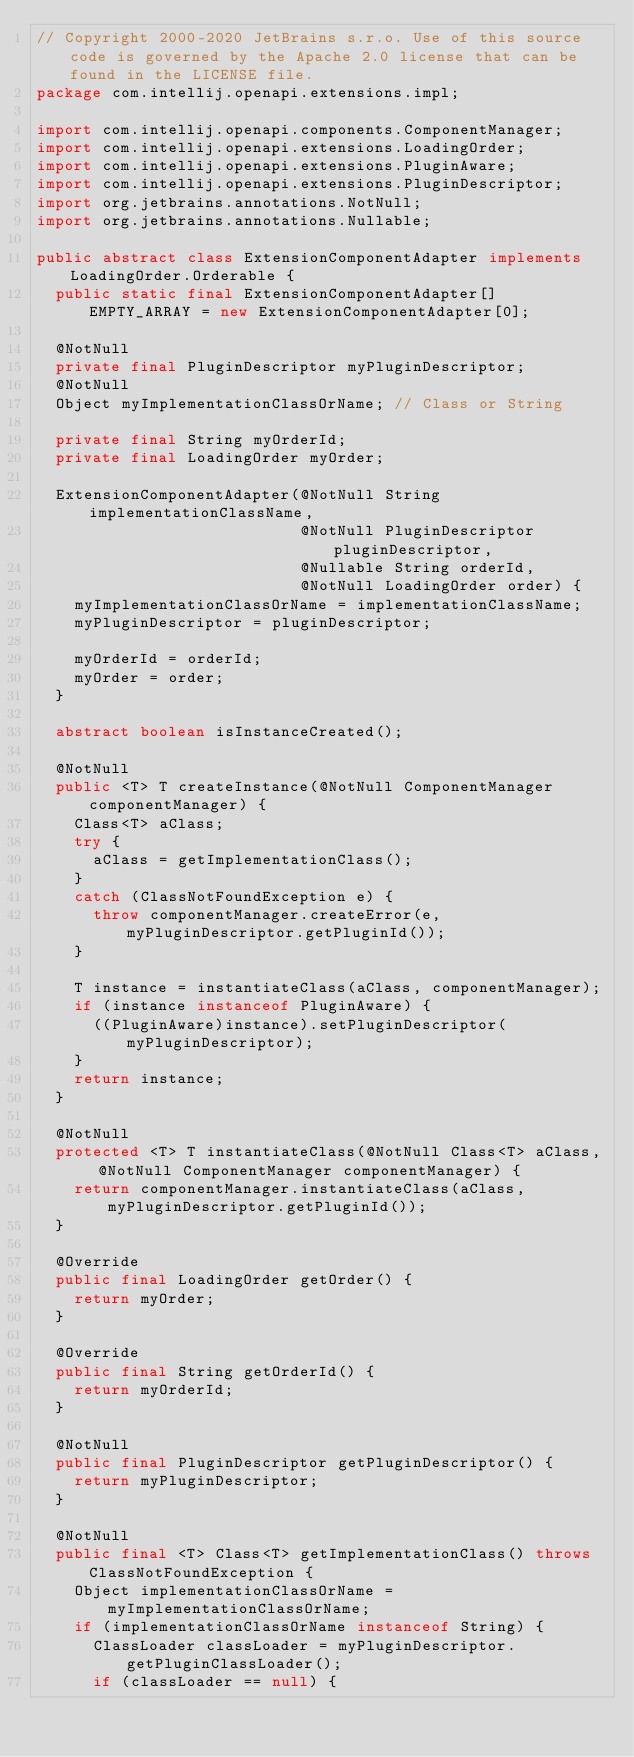Convert code to text. <code><loc_0><loc_0><loc_500><loc_500><_Java_>// Copyright 2000-2020 JetBrains s.r.o. Use of this source code is governed by the Apache 2.0 license that can be found in the LICENSE file.
package com.intellij.openapi.extensions.impl;

import com.intellij.openapi.components.ComponentManager;
import com.intellij.openapi.extensions.LoadingOrder;
import com.intellij.openapi.extensions.PluginAware;
import com.intellij.openapi.extensions.PluginDescriptor;
import org.jetbrains.annotations.NotNull;
import org.jetbrains.annotations.Nullable;

public abstract class ExtensionComponentAdapter implements LoadingOrder.Orderable {
  public static final ExtensionComponentAdapter[] EMPTY_ARRAY = new ExtensionComponentAdapter[0];

  @NotNull
  private final PluginDescriptor myPluginDescriptor;
  @NotNull
  Object myImplementationClassOrName; // Class or String

  private final String myOrderId;
  private final LoadingOrder myOrder;

  ExtensionComponentAdapter(@NotNull String implementationClassName,
                            @NotNull PluginDescriptor pluginDescriptor,
                            @Nullable String orderId,
                            @NotNull LoadingOrder order) {
    myImplementationClassOrName = implementationClassName;
    myPluginDescriptor = pluginDescriptor;

    myOrderId = orderId;
    myOrder = order;
  }

  abstract boolean isInstanceCreated();

  @NotNull
  public <T> T createInstance(@NotNull ComponentManager componentManager) {
    Class<T> aClass;
    try {
      aClass = getImplementationClass();
    }
    catch (ClassNotFoundException e) {
      throw componentManager.createError(e, myPluginDescriptor.getPluginId());
    }

    T instance = instantiateClass(aClass, componentManager);
    if (instance instanceof PluginAware) {
      ((PluginAware)instance).setPluginDescriptor(myPluginDescriptor);
    }
    return instance;
  }

  @NotNull
  protected <T> T instantiateClass(@NotNull Class<T> aClass, @NotNull ComponentManager componentManager) {
    return componentManager.instantiateClass(aClass, myPluginDescriptor.getPluginId());
  }

  @Override
  public final LoadingOrder getOrder() {
    return myOrder;
  }

  @Override
  public final String getOrderId() {
    return myOrderId;
  }

  @NotNull
  public final PluginDescriptor getPluginDescriptor() {
    return myPluginDescriptor;
  }

  @NotNull
  public final <T> Class<T> getImplementationClass() throws ClassNotFoundException {
    Object implementationClassOrName = myImplementationClassOrName;
    if (implementationClassOrName instanceof String) {
      ClassLoader classLoader = myPluginDescriptor.getPluginClassLoader();
      if (classLoader == null) {</code> 